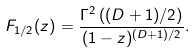Convert formula to latex. <formula><loc_0><loc_0><loc_500><loc_500>F _ { 1 / 2 } ( z ) = \frac { \Gamma ^ { 2 } \left ( ( D + 1 ) / 2 \right ) } { ( 1 - z ) ^ { ( D + 1 ) / 2 } } .</formula> 